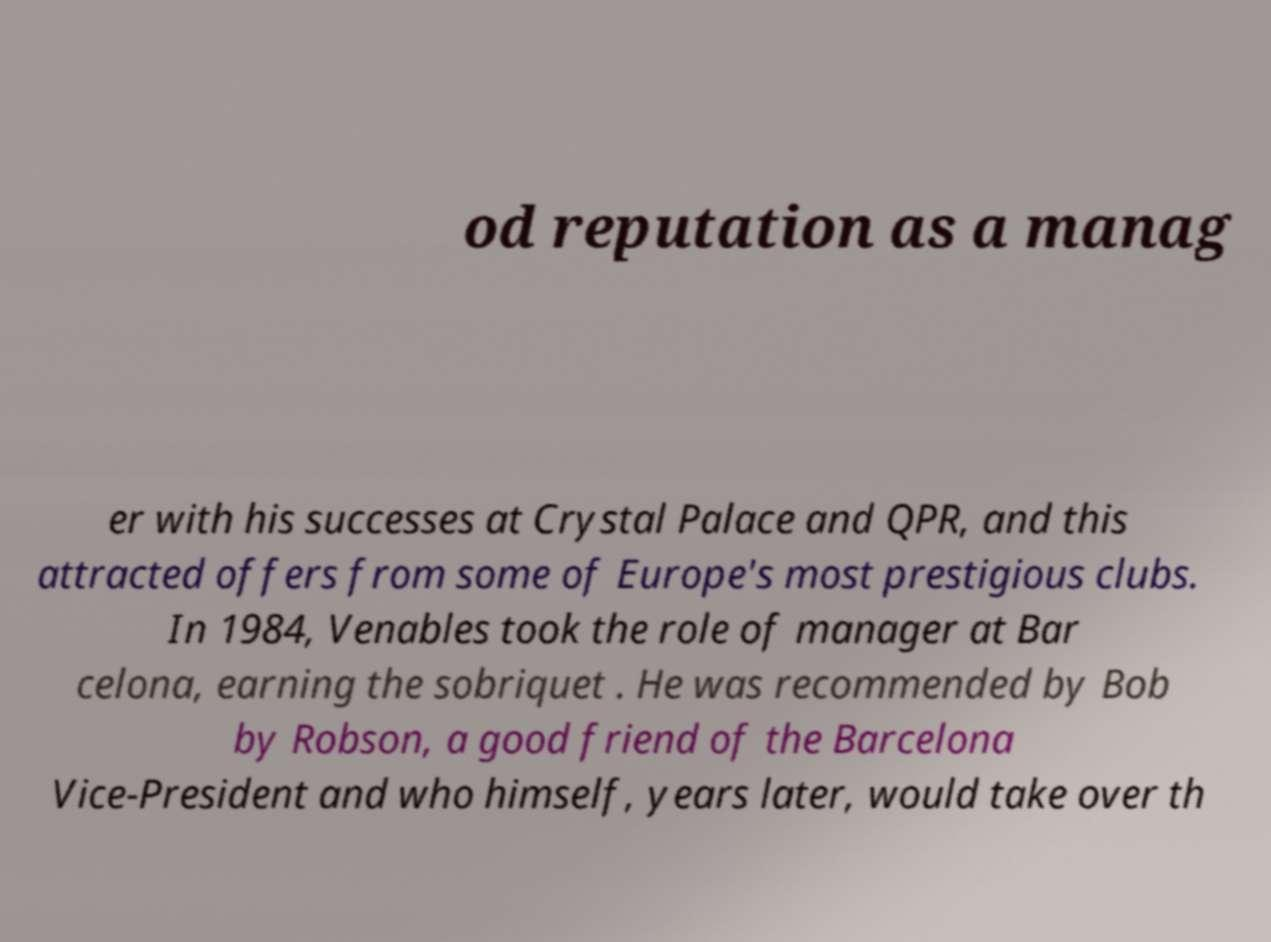What messages or text are displayed in this image? I need them in a readable, typed format. od reputation as a manag er with his successes at Crystal Palace and QPR, and this attracted offers from some of Europe's most prestigious clubs. In 1984, Venables took the role of manager at Bar celona, earning the sobriquet . He was recommended by Bob by Robson, a good friend of the Barcelona Vice-President and who himself, years later, would take over th 